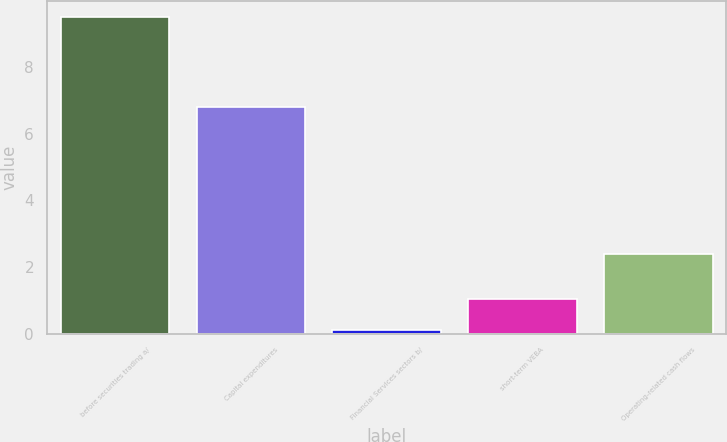Convert chart to OTSL. <chart><loc_0><loc_0><loc_500><loc_500><bar_chart><fcel>before securities trading a/<fcel>Capital expenditures<fcel>Financial Services sectors b/<fcel>short-term VEBA<fcel>Operating-related cash flows<nl><fcel>9.5<fcel>6.8<fcel>0.1<fcel>1.04<fcel>2.4<nl></chart> 